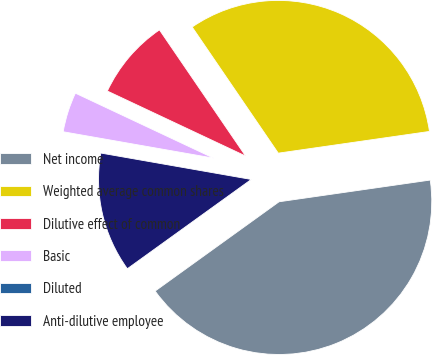Convert chart. <chart><loc_0><loc_0><loc_500><loc_500><pie_chart><fcel>Net income<fcel>Weighted average common shares<fcel>Dilutive effect of common<fcel>Basic<fcel>Diluted<fcel>Anti-dilutive employee<nl><fcel>42.33%<fcel>32.26%<fcel>8.47%<fcel>4.23%<fcel>0.0%<fcel>12.7%<nl></chart> 